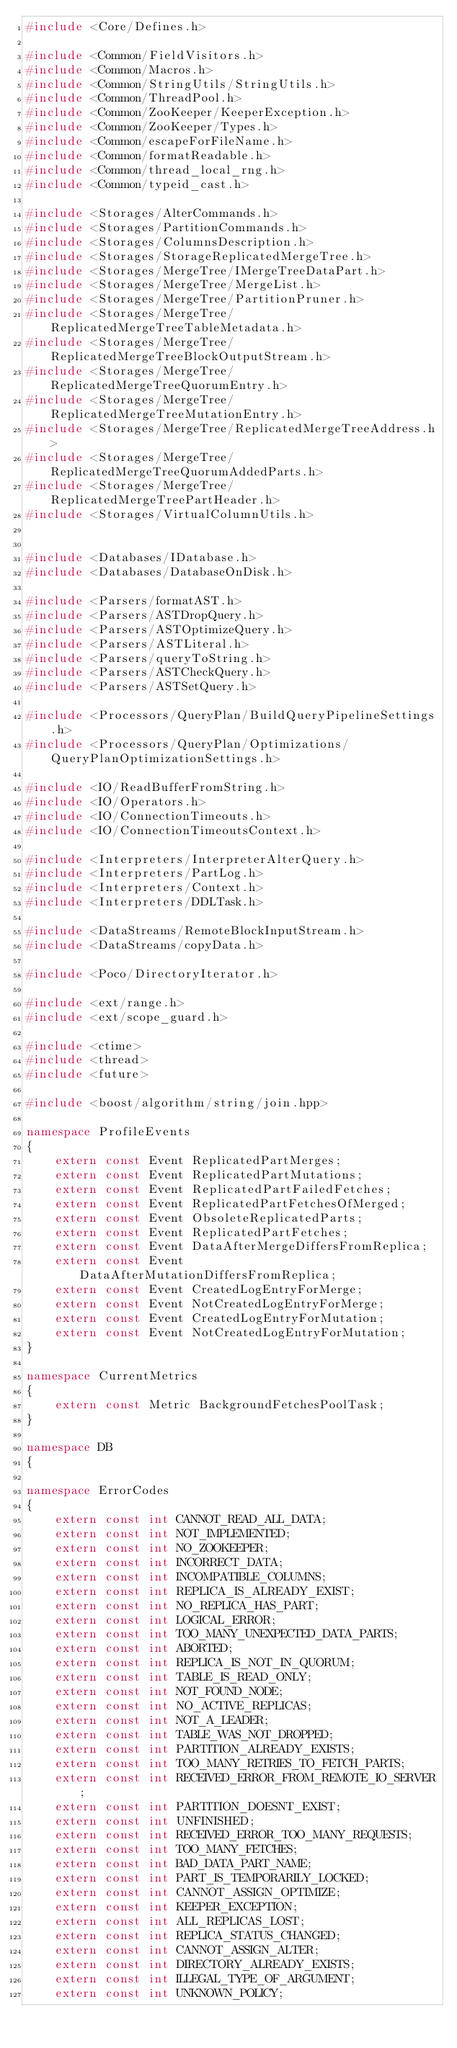Convert code to text. <code><loc_0><loc_0><loc_500><loc_500><_C++_>#include <Core/Defines.h>

#include <Common/FieldVisitors.h>
#include <Common/Macros.h>
#include <Common/StringUtils/StringUtils.h>
#include <Common/ThreadPool.h>
#include <Common/ZooKeeper/KeeperException.h>
#include <Common/ZooKeeper/Types.h>
#include <Common/escapeForFileName.h>
#include <Common/formatReadable.h>
#include <Common/thread_local_rng.h>
#include <Common/typeid_cast.h>

#include <Storages/AlterCommands.h>
#include <Storages/PartitionCommands.h>
#include <Storages/ColumnsDescription.h>
#include <Storages/StorageReplicatedMergeTree.h>
#include <Storages/MergeTree/IMergeTreeDataPart.h>
#include <Storages/MergeTree/MergeList.h>
#include <Storages/MergeTree/PartitionPruner.h>
#include <Storages/MergeTree/ReplicatedMergeTreeTableMetadata.h>
#include <Storages/MergeTree/ReplicatedMergeTreeBlockOutputStream.h>
#include <Storages/MergeTree/ReplicatedMergeTreeQuorumEntry.h>
#include <Storages/MergeTree/ReplicatedMergeTreeMutationEntry.h>
#include <Storages/MergeTree/ReplicatedMergeTreeAddress.h>
#include <Storages/MergeTree/ReplicatedMergeTreeQuorumAddedParts.h>
#include <Storages/MergeTree/ReplicatedMergeTreePartHeader.h>
#include <Storages/VirtualColumnUtils.h>


#include <Databases/IDatabase.h>
#include <Databases/DatabaseOnDisk.h>

#include <Parsers/formatAST.h>
#include <Parsers/ASTDropQuery.h>
#include <Parsers/ASTOptimizeQuery.h>
#include <Parsers/ASTLiteral.h>
#include <Parsers/queryToString.h>
#include <Parsers/ASTCheckQuery.h>
#include <Parsers/ASTSetQuery.h>

#include <Processors/QueryPlan/BuildQueryPipelineSettings.h>
#include <Processors/QueryPlan/Optimizations/QueryPlanOptimizationSettings.h>

#include <IO/ReadBufferFromString.h>
#include <IO/Operators.h>
#include <IO/ConnectionTimeouts.h>
#include <IO/ConnectionTimeoutsContext.h>

#include <Interpreters/InterpreterAlterQuery.h>
#include <Interpreters/PartLog.h>
#include <Interpreters/Context.h>
#include <Interpreters/DDLTask.h>

#include <DataStreams/RemoteBlockInputStream.h>
#include <DataStreams/copyData.h>

#include <Poco/DirectoryIterator.h>

#include <ext/range.h>
#include <ext/scope_guard.h>

#include <ctime>
#include <thread>
#include <future>

#include <boost/algorithm/string/join.hpp>

namespace ProfileEvents
{
    extern const Event ReplicatedPartMerges;
    extern const Event ReplicatedPartMutations;
    extern const Event ReplicatedPartFailedFetches;
    extern const Event ReplicatedPartFetchesOfMerged;
    extern const Event ObsoleteReplicatedParts;
    extern const Event ReplicatedPartFetches;
    extern const Event DataAfterMergeDiffersFromReplica;
    extern const Event DataAfterMutationDiffersFromReplica;
    extern const Event CreatedLogEntryForMerge;
    extern const Event NotCreatedLogEntryForMerge;
    extern const Event CreatedLogEntryForMutation;
    extern const Event NotCreatedLogEntryForMutation;
}

namespace CurrentMetrics
{
    extern const Metric BackgroundFetchesPoolTask;
}

namespace DB
{

namespace ErrorCodes
{
    extern const int CANNOT_READ_ALL_DATA;
    extern const int NOT_IMPLEMENTED;
    extern const int NO_ZOOKEEPER;
    extern const int INCORRECT_DATA;
    extern const int INCOMPATIBLE_COLUMNS;
    extern const int REPLICA_IS_ALREADY_EXIST;
    extern const int NO_REPLICA_HAS_PART;
    extern const int LOGICAL_ERROR;
    extern const int TOO_MANY_UNEXPECTED_DATA_PARTS;
    extern const int ABORTED;
    extern const int REPLICA_IS_NOT_IN_QUORUM;
    extern const int TABLE_IS_READ_ONLY;
    extern const int NOT_FOUND_NODE;
    extern const int NO_ACTIVE_REPLICAS;
    extern const int NOT_A_LEADER;
    extern const int TABLE_WAS_NOT_DROPPED;
    extern const int PARTITION_ALREADY_EXISTS;
    extern const int TOO_MANY_RETRIES_TO_FETCH_PARTS;
    extern const int RECEIVED_ERROR_FROM_REMOTE_IO_SERVER;
    extern const int PARTITION_DOESNT_EXIST;
    extern const int UNFINISHED;
    extern const int RECEIVED_ERROR_TOO_MANY_REQUESTS;
    extern const int TOO_MANY_FETCHES;
    extern const int BAD_DATA_PART_NAME;
    extern const int PART_IS_TEMPORARILY_LOCKED;
    extern const int CANNOT_ASSIGN_OPTIMIZE;
    extern const int KEEPER_EXCEPTION;
    extern const int ALL_REPLICAS_LOST;
    extern const int REPLICA_STATUS_CHANGED;
    extern const int CANNOT_ASSIGN_ALTER;
    extern const int DIRECTORY_ALREADY_EXISTS;
    extern const int ILLEGAL_TYPE_OF_ARGUMENT;
    extern const int UNKNOWN_POLICY;</code> 